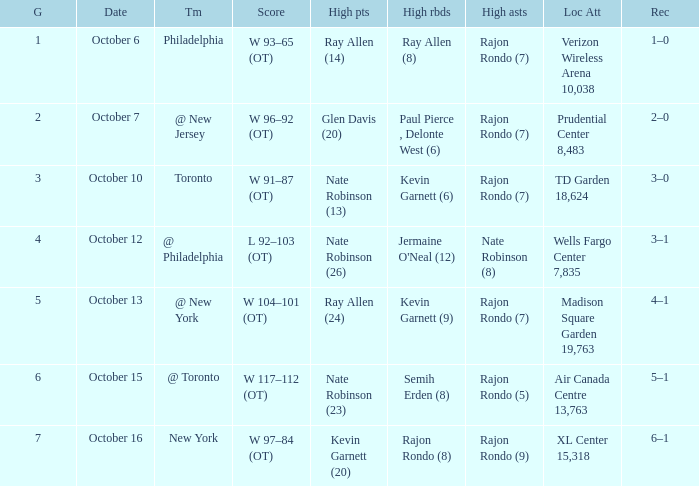Who had the most rebounds and how many did they have on October 16? Rajon Rondo (8). 